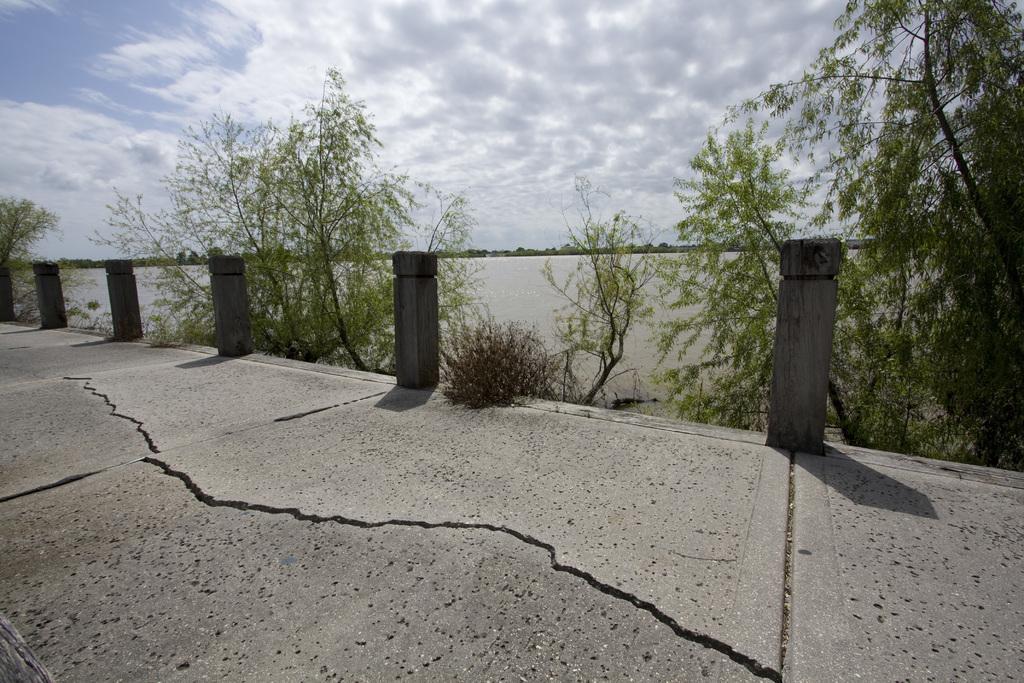Could you give a brief overview of what you see in this image? In this picture there is a pavement and there are pillars in the foreground. At the back there are trees. At the top there is sky and there are clouds. At the bottom there is water. 